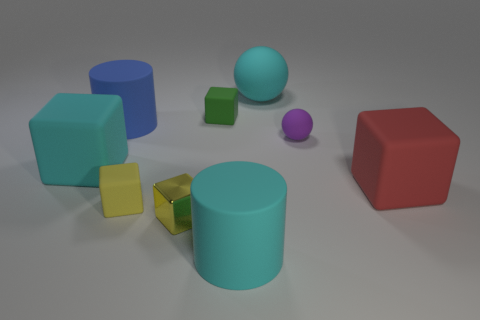Is the number of small yellow things left of the red object greater than the number of balls that are to the left of the purple matte object?
Offer a very short reply. Yes. There is a cyan ball that is made of the same material as the big cyan cube; what size is it?
Your answer should be very brief. Large. There is a cube that is behind the cylinder that is left of the block in front of the small yellow matte object; how big is it?
Offer a terse response. Small. There is a large cylinder on the left side of the cyan rubber cylinder; what color is it?
Make the answer very short. Blue. Are there more rubber cylinders that are behind the large cyan rubber cube than blue metallic things?
Provide a short and direct response. Yes. There is a large blue thing behind the yellow shiny block; is its shape the same as the small green thing?
Your answer should be very brief. No. What number of red things are big rubber cubes or tiny rubber things?
Provide a short and direct response. 1. Is the number of purple objects greater than the number of large yellow balls?
Your answer should be compact. Yes. There is a ball that is the same size as the cyan block; what color is it?
Your answer should be very brief. Cyan. How many cylinders are blue matte things or big rubber objects?
Make the answer very short. 2. 